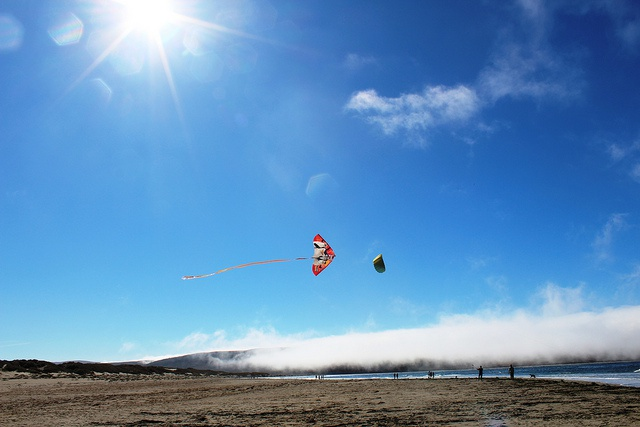Describe the objects in this image and their specific colors. I can see kite in gray, lightblue, darkgray, red, and black tones, kite in gray, black, teal, olive, and darkgreen tones, people in gray, black, maroon, and purple tones, people in gray, black, and darkblue tones, and dog in gray, black, darkblue, and blue tones in this image. 